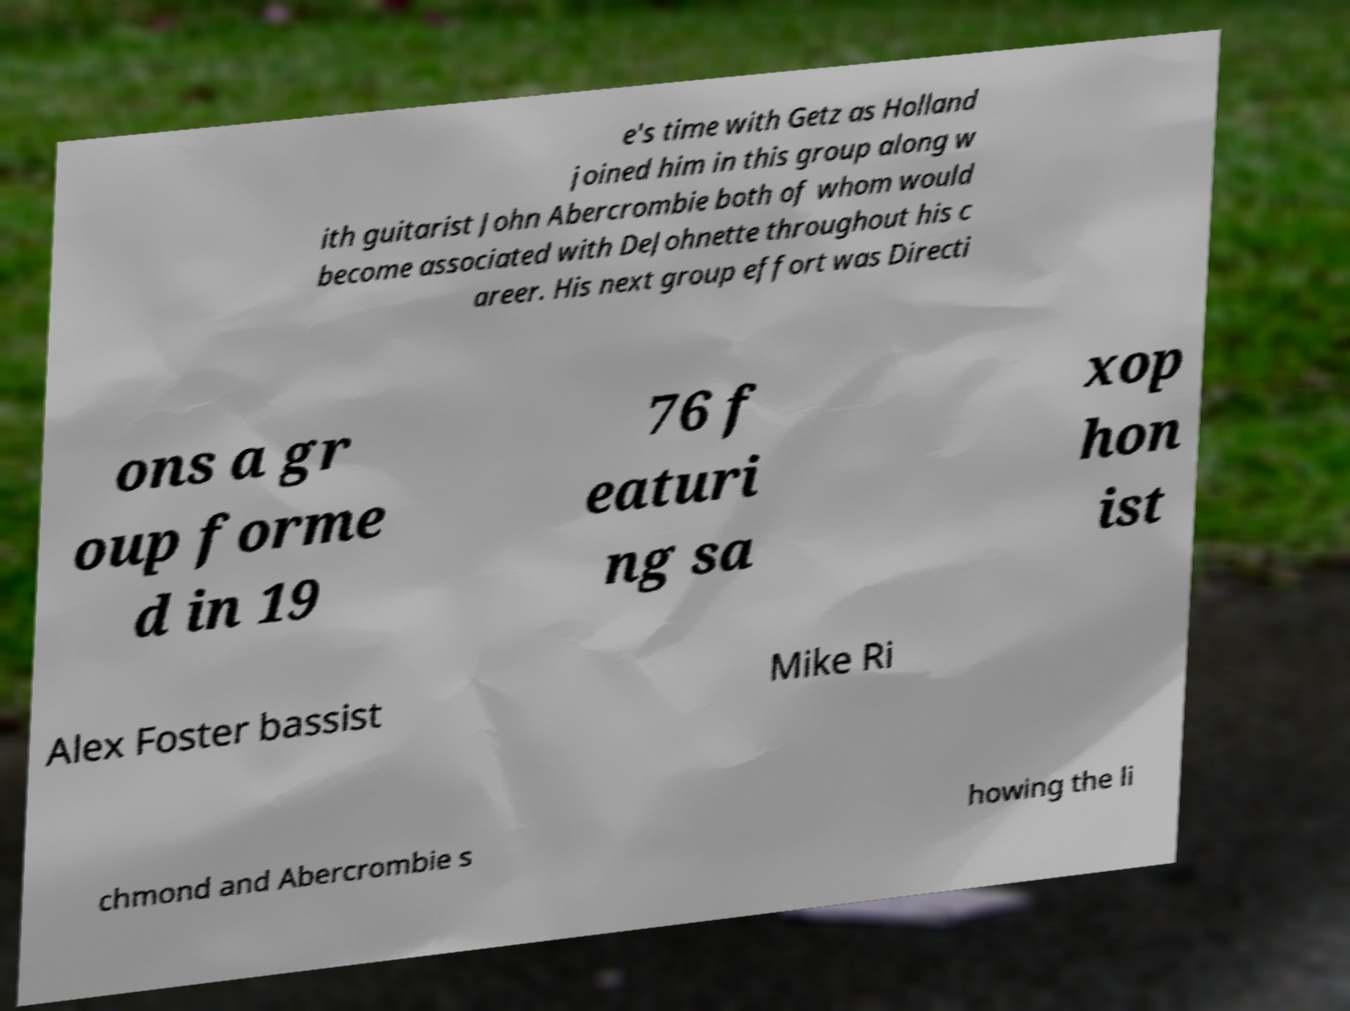Can you accurately transcribe the text from the provided image for me? e's time with Getz as Holland joined him in this group along w ith guitarist John Abercrombie both of whom would become associated with DeJohnette throughout his c areer. His next group effort was Directi ons a gr oup forme d in 19 76 f eaturi ng sa xop hon ist Alex Foster bassist Mike Ri chmond and Abercrombie s howing the li 